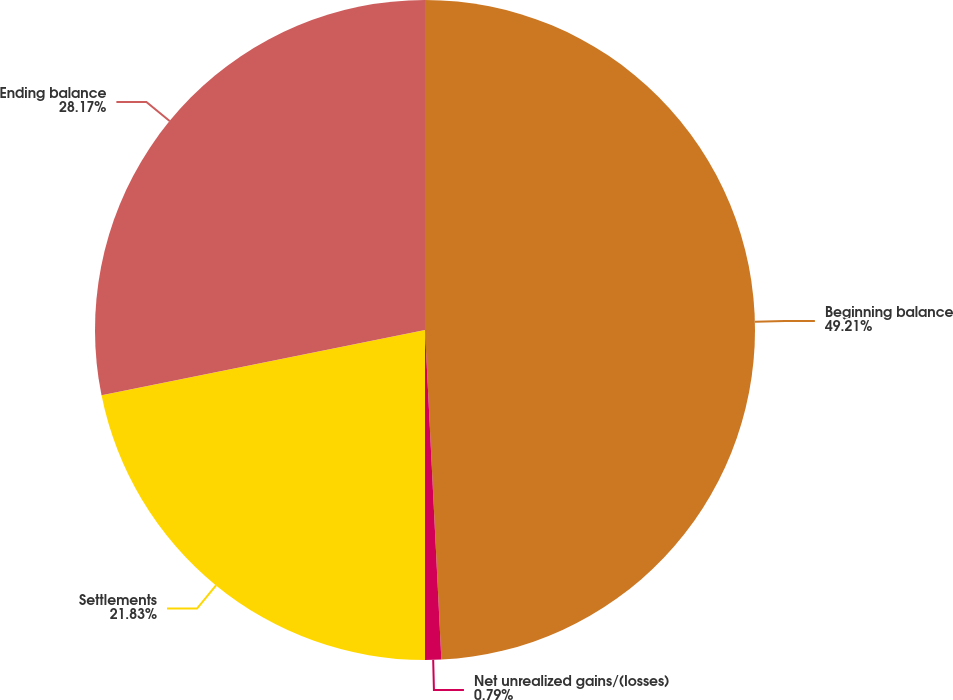Convert chart. <chart><loc_0><loc_0><loc_500><loc_500><pie_chart><fcel>Beginning balance<fcel>Net unrealized gains/(losses)<fcel>Settlements<fcel>Ending balance<nl><fcel>49.21%<fcel>0.79%<fcel>21.83%<fcel>28.17%<nl></chart> 